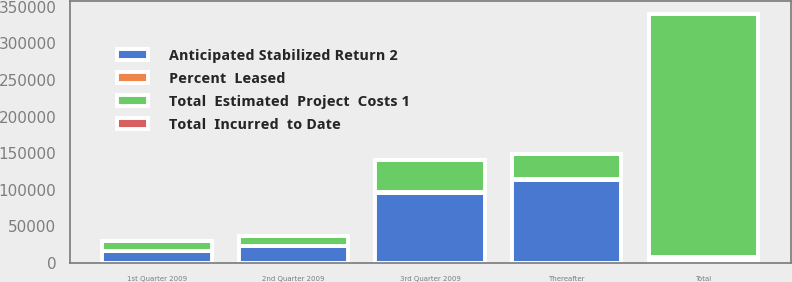<chart> <loc_0><loc_0><loc_500><loc_500><stacked_bar_chart><ecel><fcel>1st Quarter 2009<fcel>2nd Quarter 2009<fcel>3rd Quarter 2009<fcel>Thereafter<fcel>Total<nl><fcel>Percent  Leased<fcel>93<fcel>523<fcel>428<fcel>401<fcel>4021<nl><fcel>Total  Incurred  to Date<fcel>100<fcel>0<fcel>57<fcel>52<fcel>46<nl><fcel>Anticipated Stabilized Return 2<fcel>16776<fcel>23130<fcel>96214<fcel>113660<fcel>4021<nl><fcel>Total  Estimated  Project  Costs 1<fcel>12749<fcel>13307<fcel>43460<fcel>34277<fcel>332116<nl></chart> 